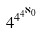<formula> <loc_0><loc_0><loc_500><loc_500>4 ^ { 4 ^ { 4 ^ { \aleph _ { 0 } } } }</formula> 